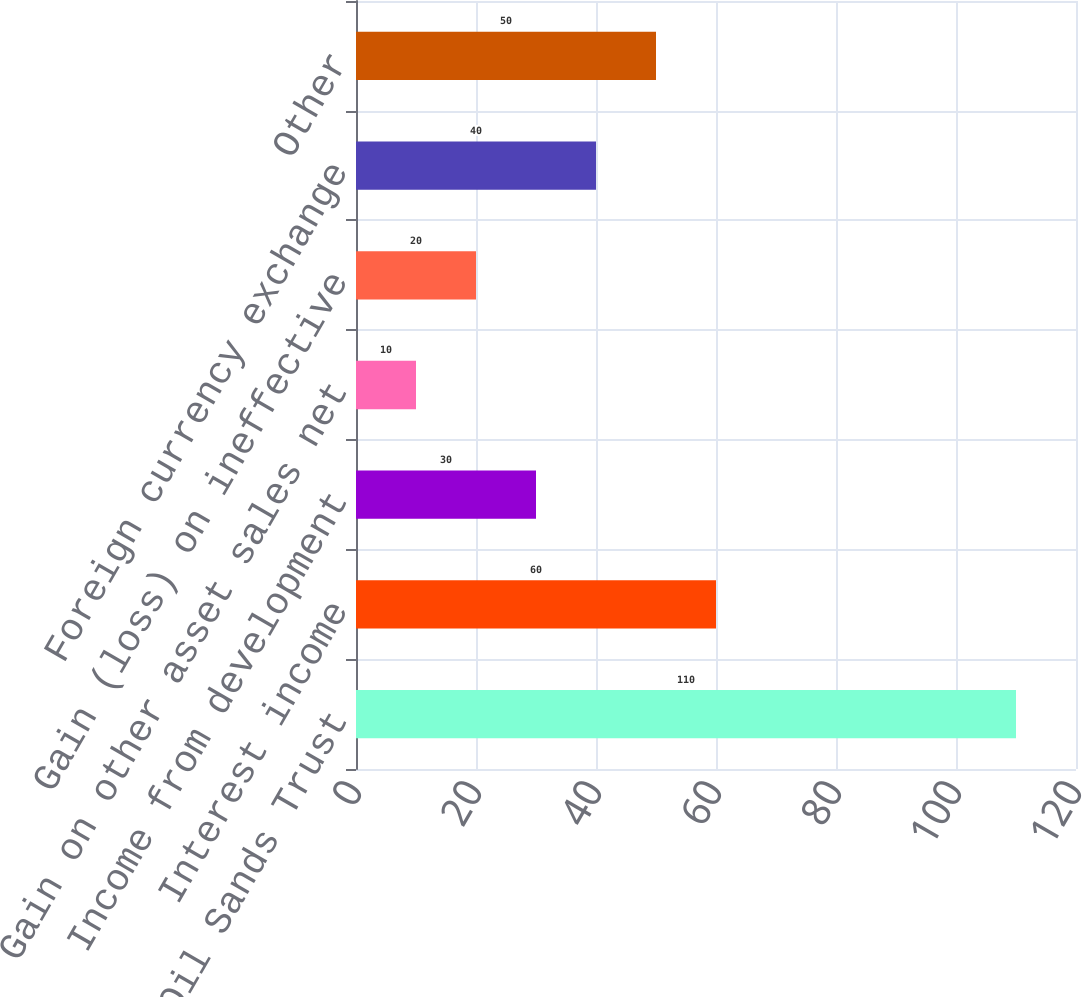<chart> <loc_0><loc_0><loc_500><loc_500><bar_chart><fcel>Canadian Oil Sands Trust<fcel>Interest income<fcel>Income from development<fcel>Gain on other asset sales net<fcel>Gain (loss) on ineffective<fcel>Foreign currency exchange<fcel>Other<nl><fcel>110<fcel>60<fcel>30<fcel>10<fcel>20<fcel>40<fcel>50<nl></chart> 